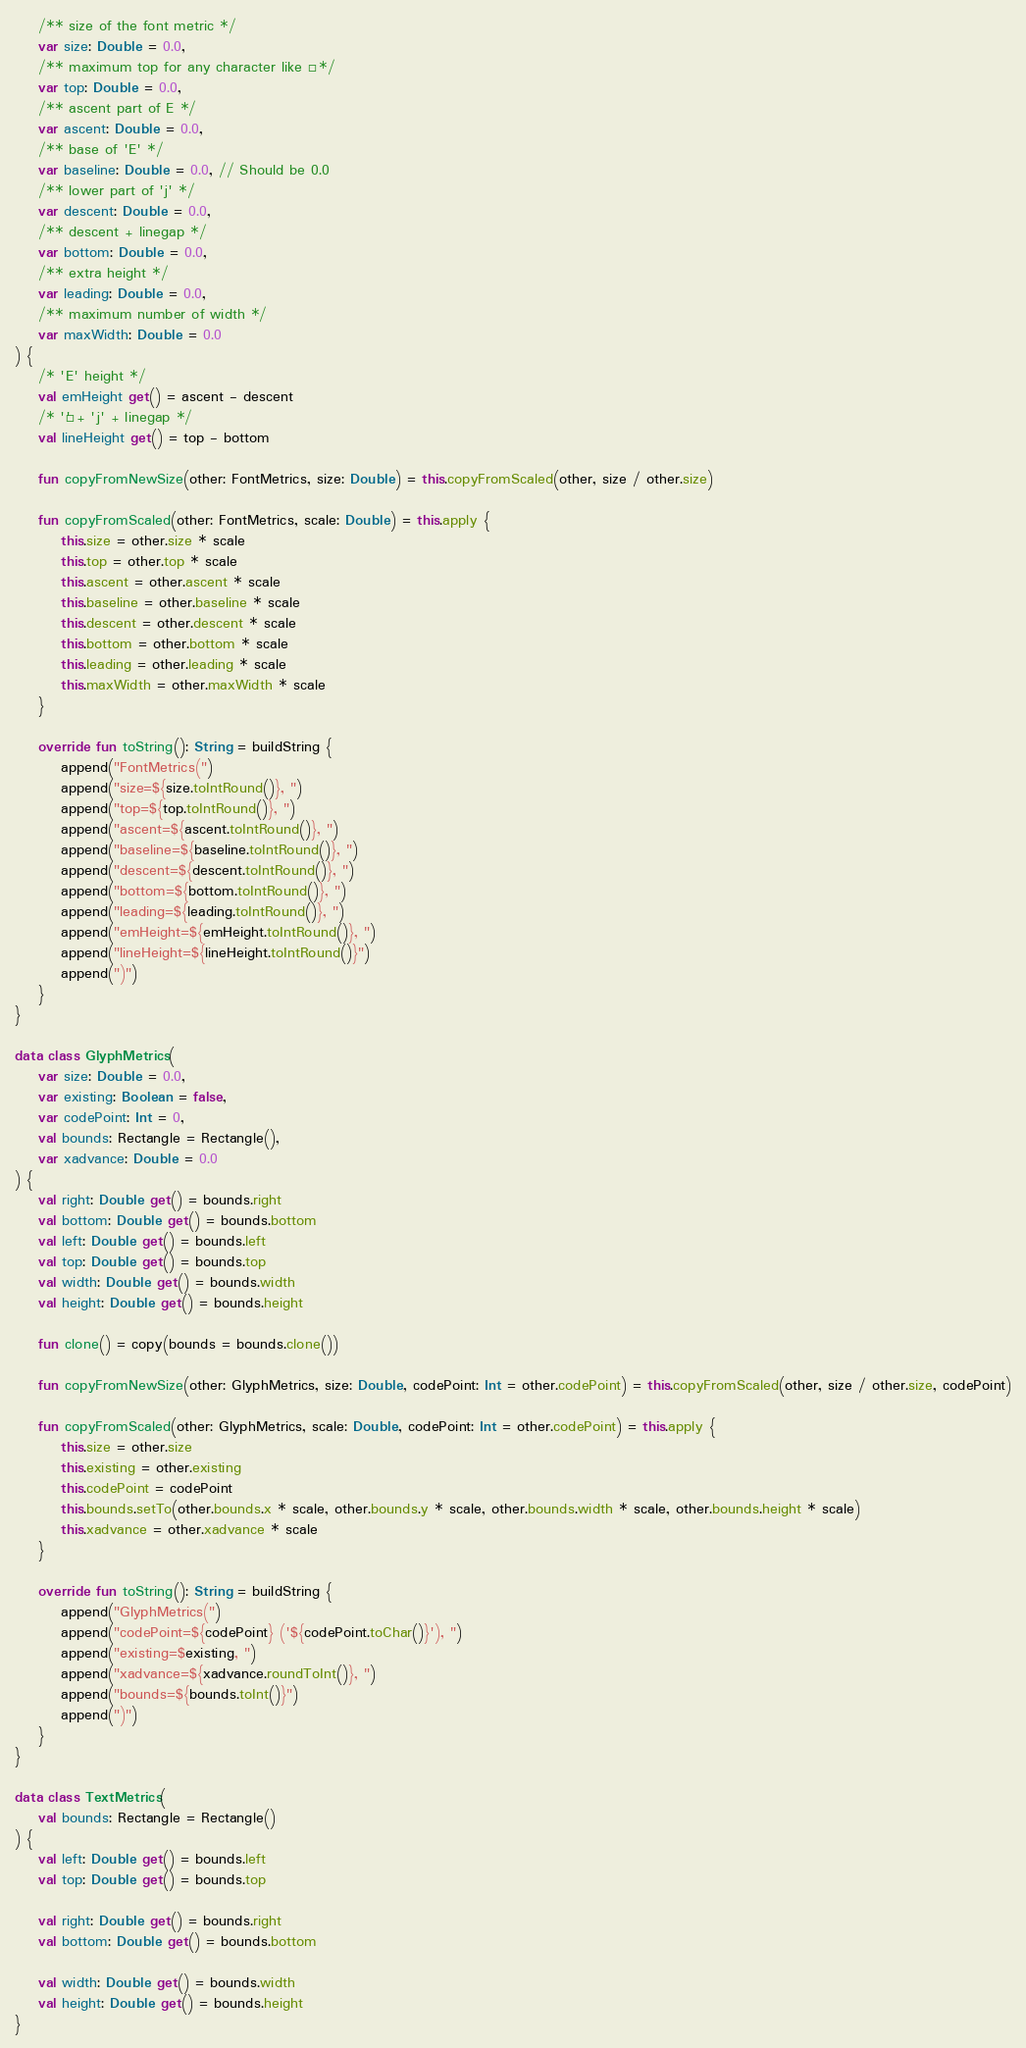<code> <loc_0><loc_0><loc_500><loc_500><_Kotlin_>    /** size of the font metric */
    var size: Double = 0.0,
    /** maximum top for any character like É  */
    var top: Double = 0.0,
    /** ascent part of E */
    var ascent: Double = 0.0,
    /** base of 'E' */
    var baseline: Double = 0.0, // Should be 0.0
    /** lower part of 'j' */
    var descent: Double = 0.0,
    /** descent + linegap */
    var bottom: Double = 0.0,
    /** extra height */
    var leading: Double = 0.0,
    /** maximum number of width */
    var maxWidth: Double = 0.0
) {
    /* 'E' height */
    val emHeight get() = ascent - descent
    /* 'É' + 'j' + linegap */
    val lineHeight get() = top - bottom

    fun copyFromNewSize(other: FontMetrics, size: Double) = this.copyFromScaled(other, size / other.size)

    fun copyFromScaled(other: FontMetrics, scale: Double) = this.apply {
        this.size = other.size * scale
        this.top = other.top * scale
        this.ascent = other.ascent * scale
        this.baseline = other.baseline * scale
        this.descent = other.descent * scale
        this.bottom = other.bottom * scale
        this.leading = other.leading * scale
        this.maxWidth = other.maxWidth * scale
    }

    override fun toString(): String = buildString {
        append("FontMetrics(")
        append("size=${size.toIntRound()}, ")
        append("top=${top.toIntRound()}, ")
        append("ascent=${ascent.toIntRound()}, ")
        append("baseline=${baseline.toIntRound()}, ")
        append("descent=${descent.toIntRound()}, ")
        append("bottom=${bottom.toIntRound()}, ")
        append("leading=${leading.toIntRound()}, ")
        append("emHeight=${emHeight.toIntRound()}, ")
        append("lineHeight=${lineHeight.toIntRound()}")
        append(")")
    }
}

data class GlyphMetrics(
    var size: Double = 0.0,
    var existing: Boolean = false,
    var codePoint: Int = 0,
    val bounds: Rectangle = Rectangle(),
    var xadvance: Double = 0.0
) {
    val right: Double get() = bounds.right
    val bottom: Double get() = bounds.bottom
    val left: Double get() = bounds.left
    val top: Double get() = bounds.top
    val width: Double get() = bounds.width
    val height: Double get() = bounds.height

    fun clone() = copy(bounds = bounds.clone())

    fun copyFromNewSize(other: GlyphMetrics, size: Double, codePoint: Int = other.codePoint) = this.copyFromScaled(other, size / other.size, codePoint)

    fun copyFromScaled(other: GlyphMetrics, scale: Double, codePoint: Int = other.codePoint) = this.apply {
        this.size = other.size
        this.existing = other.existing
        this.codePoint = codePoint
        this.bounds.setTo(other.bounds.x * scale, other.bounds.y * scale, other.bounds.width * scale, other.bounds.height * scale)
        this.xadvance = other.xadvance * scale
    }

    override fun toString(): String = buildString {
        append("GlyphMetrics(")
        append("codePoint=${codePoint} ('${codePoint.toChar()}'), ")
        append("existing=$existing, ")
        append("xadvance=${xadvance.roundToInt()}, ")
        append("bounds=${bounds.toInt()}")
        append(")")
    }
}

data class TextMetrics(
    val bounds: Rectangle = Rectangle()
) {
    val left: Double get() = bounds.left
    val top: Double get() = bounds.top

    val right: Double get() = bounds.right
    val bottom: Double get() = bounds.bottom

    val width: Double get() = bounds.width
    val height: Double get() = bounds.height
}
</code> 